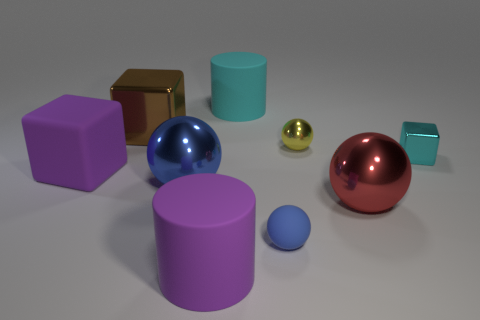Subtract all tiny yellow balls. How many balls are left? 3 Subtract all gray cylinders. How many blue balls are left? 2 Subtract all cyan cylinders. How many cylinders are left? 1 Subtract 1 cylinders. How many cylinders are left? 1 Subtract all cylinders. How many objects are left? 7 Subtract 0 blue cubes. How many objects are left? 9 Subtract all brown blocks. Subtract all purple cylinders. How many blocks are left? 2 Subtract all tiny objects. Subtract all tiny cyan cubes. How many objects are left? 5 Add 7 big purple rubber cylinders. How many big purple rubber cylinders are left? 8 Add 8 cyan things. How many cyan things exist? 10 